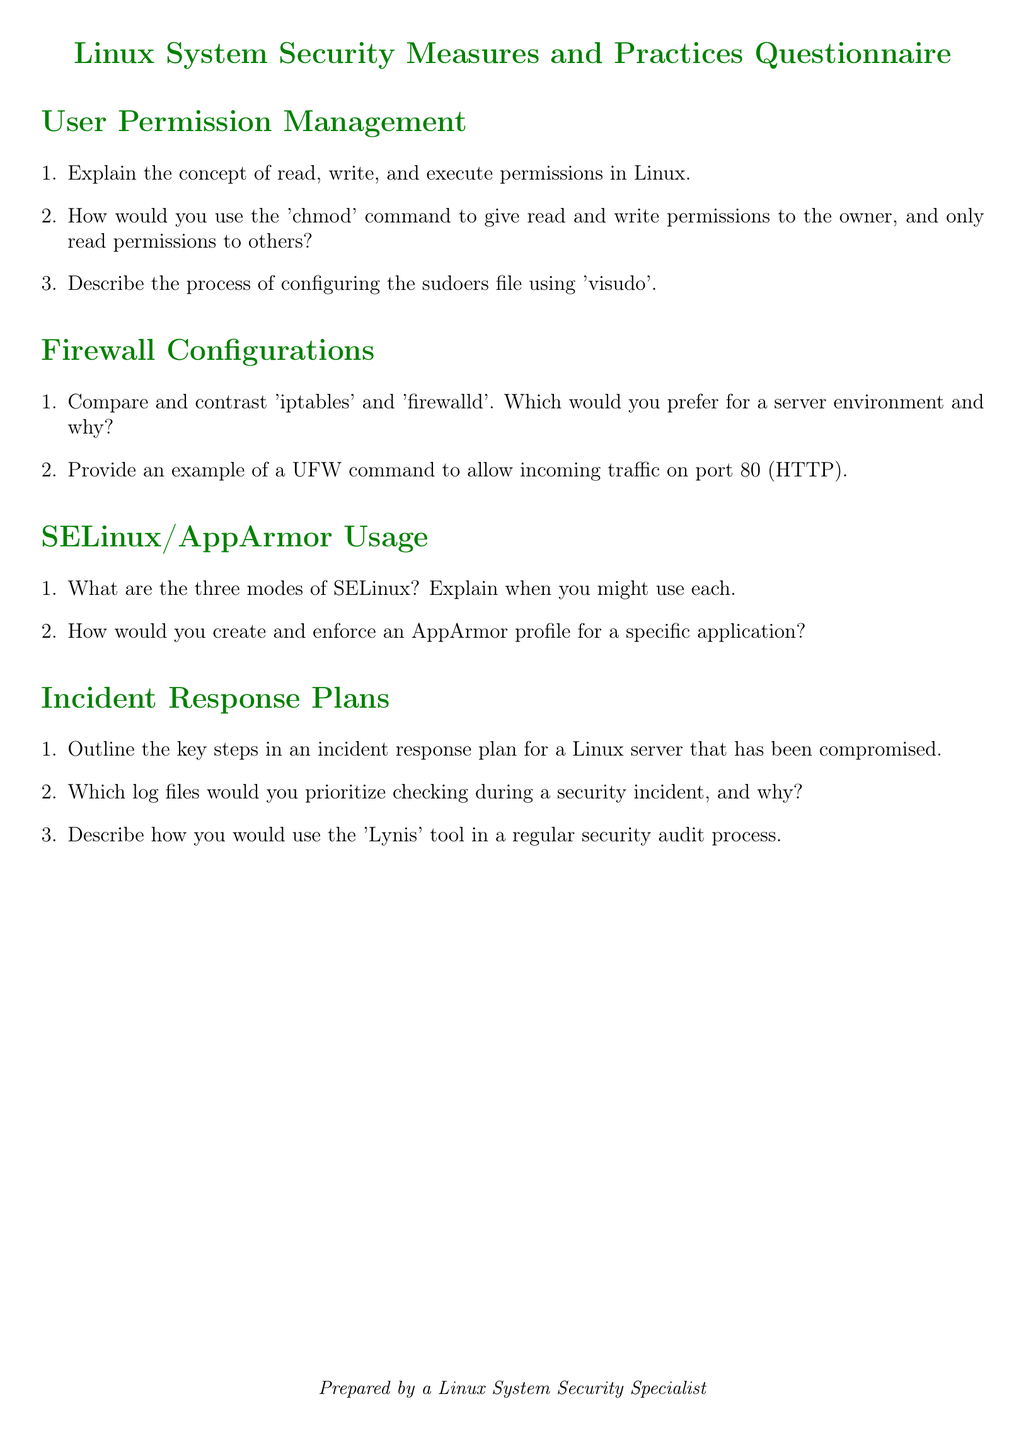What is the title of the document? The title can be found at the top of the document, which specifies its subject matter.
Answer: Linux System Security Measures and Practices Questionnaire How many sections are in the document? The document contains multiple sections, each focusing on a specific aspect of Linux security.
Answer: Four What are the three modes of SELinux? This information is found in the section discussing SELinux/AppArmor usage, detailing its operational modes.
Answer: Enforcing, permissive, disabled What command is used to modify permissions for files? This command is mentioned in the user permission management section that covers file permissions.
Answer: chmod What tool is mentioned for security auditing? This tool is referenced in the incident response plans section, specifically related to regular security assessments.
Answer: Lynis How would you describe the focus of the document? The focus is determined by the key themes and sections explored within the document.
Answer: Security protocols and practices What is the primary purpose of the 'visudo' command? This is detailed in the user permission management section regarding configuring user permissions.
Answer: Edit the sudoers file 